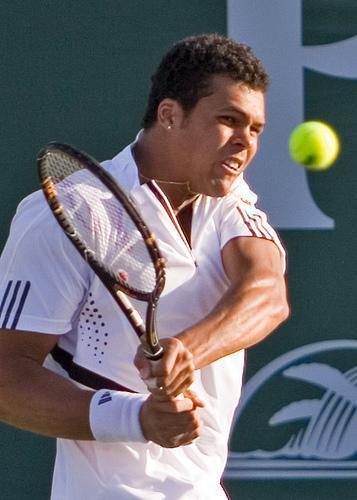How many tennis balls are there?
Give a very brief answer. 1. How many kites are in the picture?
Give a very brief answer. 0. 